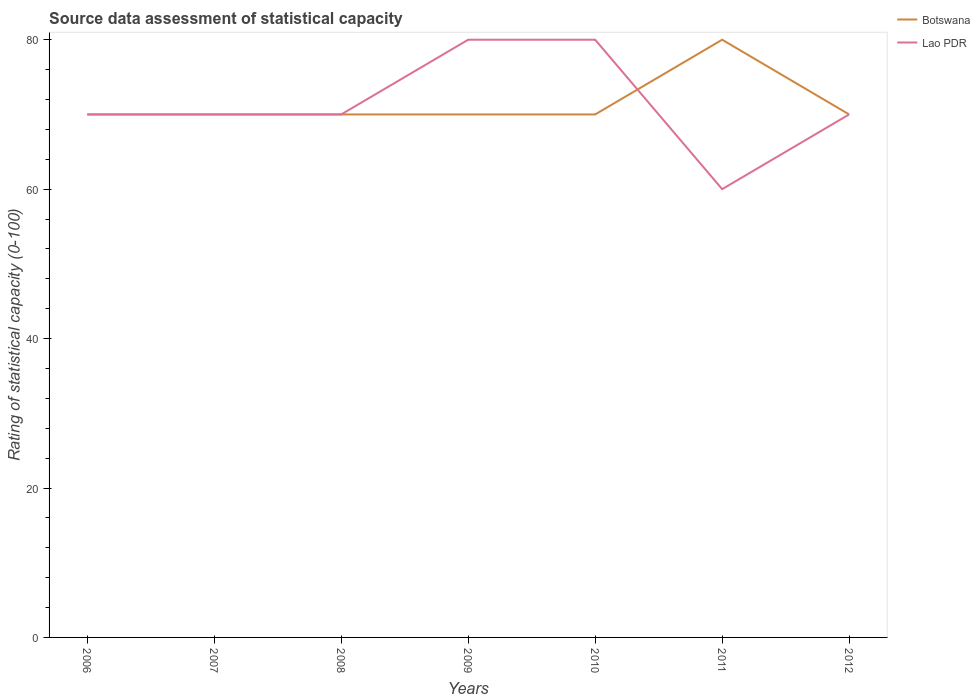Is the number of lines equal to the number of legend labels?
Your answer should be very brief. Yes. Across all years, what is the maximum rating of statistical capacity in Lao PDR?
Provide a succinct answer. 60. What is the total rating of statistical capacity in Botswana in the graph?
Make the answer very short. -10. What is the difference between the highest and the second highest rating of statistical capacity in Botswana?
Make the answer very short. 10. How many lines are there?
Your answer should be compact. 2. How many years are there in the graph?
Your answer should be compact. 7. Are the values on the major ticks of Y-axis written in scientific E-notation?
Your answer should be compact. No. Does the graph contain grids?
Offer a very short reply. No. Where does the legend appear in the graph?
Provide a succinct answer. Top right. What is the title of the graph?
Offer a very short reply. Source data assessment of statistical capacity. What is the label or title of the X-axis?
Your answer should be compact. Years. What is the label or title of the Y-axis?
Your answer should be very brief. Rating of statistical capacity (0-100). What is the Rating of statistical capacity (0-100) in Botswana in 2007?
Your answer should be compact. 70. What is the Rating of statistical capacity (0-100) in Lao PDR in 2007?
Give a very brief answer. 70. What is the Rating of statistical capacity (0-100) in Botswana in 2008?
Offer a very short reply. 70. What is the Rating of statistical capacity (0-100) of Lao PDR in 2008?
Offer a terse response. 70. What is the Rating of statistical capacity (0-100) of Lao PDR in 2010?
Offer a very short reply. 80. What is the Rating of statistical capacity (0-100) in Botswana in 2011?
Your answer should be very brief. 80. What is the Rating of statistical capacity (0-100) of Lao PDR in 2011?
Your answer should be very brief. 60. Across all years, what is the maximum Rating of statistical capacity (0-100) of Botswana?
Provide a short and direct response. 80. Across all years, what is the maximum Rating of statistical capacity (0-100) of Lao PDR?
Your response must be concise. 80. Across all years, what is the minimum Rating of statistical capacity (0-100) in Lao PDR?
Offer a very short reply. 60. What is the total Rating of statistical capacity (0-100) of Botswana in the graph?
Your answer should be compact. 500. What is the difference between the Rating of statistical capacity (0-100) in Botswana in 2006 and that in 2007?
Your answer should be very brief. 0. What is the difference between the Rating of statistical capacity (0-100) of Lao PDR in 2006 and that in 2007?
Provide a short and direct response. 0. What is the difference between the Rating of statistical capacity (0-100) of Botswana in 2006 and that in 2009?
Offer a very short reply. 0. What is the difference between the Rating of statistical capacity (0-100) of Botswana in 2006 and that in 2010?
Keep it short and to the point. 0. What is the difference between the Rating of statistical capacity (0-100) of Botswana in 2006 and that in 2011?
Give a very brief answer. -10. What is the difference between the Rating of statistical capacity (0-100) of Lao PDR in 2006 and that in 2011?
Provide a succinct answer. 10. What is the difference between the Rating of statistical capacity (0-100) of Botswana in 2007 and that in 2009?
Keep it short and to the point. 0. What is the difference between the Rating of statistical capacity (0-100) in Lao PDR in 2007 and that in 2009?
Give a very brief answer. -10. What is the difference between the Rating of statistical capacity (0-100) in Lao PDR in 2007 and that in 2010?
Provide a short and direct response. -10. What is the difference between the Rating of statistical capacity (0-100) of Botswana in 2007 and that in 2011?
Give a very brief answer. -10. What is the difference between the Rating of statistical capacity (0-100) in Lao PDR in 2007 and that in 2011?
Offer a terse response. 10. What is the difference between the Rating of statistical capacity (0-100) of Botswana in 2007 and that in 2012?
Make the answer very short. 0. What is the difference between the Rating of statistical capacity (0-100) of Botswana in 2008 and that in 2009?
Your response must be concise. 0. What is the difference between the Rating of statistical capacity (0-100) of Lao PDR in 2008 and that in 2010?
Your answer should be compact. -10. What is the difference between the Rating of statistical capacity (0-100) in Lao PDR in 2008 and that in 2011?
Make the answer very short. 10. What is the difference between the Rating of statistical capacity (0-100) in Botswana in 2008 and that in 2012?
Offer a terse response. 0. What is the difference between the Rating of statistical capacity (0-100) in Lao PDR in 2008 and that in 2012?
Offer a terse response. 0. What is the difference between the Rating of statistical capacity (0-100) in Botswana in 2009 and that in 2010?
Your response must be concise. 0. What is the difference between the Rating of statistical capacity (0-100) of Botswana in 2009 and that in 2012?
Your response must be concise. 0. What is the difference between the Rating of statistical capacity (0-100) in Lao PDR in 2010 and that in 2012?
Offer a very short reply. 10. What is the difference between the Rating of statistical capacity (0-100) of Botswana in 2006 and the Rating of statistical capacity (0-100) of Lao PDR in 2007?
Make the answer very short. 0. What is the difference between the Rating of statistical capacity (0-100) in Botswana in 2006 and the Rating of statistical capacity (0-100) in Lao PDR in 2008?
Ensure brevity in your answer.  0. What is the difference between the Rating of statistical capacity (0-100) in Botswana in 2007 and the Rating of statistical capacity (0-100) in Lao PDR in 2009?
Your response must be concise. -10. What is the difference between the Rating of statistical capacity (0-100) in Botswana in 2007 and the Rating of statistical capacity (0-100) in Lao PDR in 2010?
Your answer should be very brief. -10. What is the difference between the Rating of statistical capacity (0-100) of Botswana in 2008 and the Rating of statistical capacity (0-100) of Lao PDR in 2012?
Make the answer very short. 0. What is the difference between the Rating of statistical capacity (0-100) in Botswana in 2010 and the Rating of statistical capacity (0-100) in Lao PDR in 2011?
Your answer should be compact. 10. What is the difference between the Rating of statistical capacity (0-100) in Botswana in 2011 and the Rating of statistical capacity (0-100) in Lao PDR in 2012?
Your response must be concise. 10. What is the average Rating of statistical capacity (0-100) of Botswana per year?
Give a very brief answer. 71.43. What is the average Rating of statistical capacity (0-100) of Lao PDR per year?
Keep it short and to the point. 71.43. In the year 2007, what is the difference between the Rating of statistical capacity (0-100) of Botswana and Rating of statistical capacity (0-100) of Lao PDR?
Give a very brief answer. 0. In the year 2008, what is the difference between the Rating of statistical capacity (0-100) of Botswana and Rating of statistical capacity (0-100) of Lao PDR?
Offer a terse response. 0. In the year 2009, what is the difference between the Rating of statistical capacity (0-100) of Botswana and Rating of statistical capacity (0-100) of Lao PDR?
Your answer should be compact. -10. In the year 2010, what is the difference between the Rating of statistical capacity (0-100) in Botswana and Rating of statistical capacity (0-100) in Lao PDR?
Provide a short and direct response. -10. What is the ratio of the Rating of statistical capacity (0-100) in Lao PDR in 2006 to that in 2008?
Your response must be concise. 1. What is the ratio of the Rating of statistical capacity (0-100) of Botswana in 2006 to that in 2009?
Offer a terse response. 1. What is the ratio of the Rating of statistical capacity (0-100) of Lao PDR in 2006 to that in 2010?
Offer a terse response. 0.88. What is the ratio of the Rating of statistical capacity (0-100) of Botswana in 2007 to that in 2008?
Give a very brief answer. 1. What is the ratio of the Rating of statistical capacity (0-100) in Botswana in 2007 to that in 2010?
Your response must be concise. 1. What is the ratio of the Rating of statistical capacity (0-100) in Botswana in 2008 to that in 2009?
Your response must be concise. 1. What is the ratio of the Rating of statistical capacity (0-100) in Botswana in 2008 to that in 2011?
Provide a short and direct response. 0.88. What is the ratio of the Rating of statistical capacity (0-100) of Lao PDR in 2008 to that in 2011?
Give a very brief answer. 1.17. What is the ratio of the Rating of statistical capacity (0-100) in Lao PDR in 2008 to that in 2012?
Offer a very short reply. 1. What is the ratio of the Rating of statistical capacity (0-100) of Botswana in 2009 to that in 2011?
Your response must be concise. 0.88. What is the ratio of the Rating of statistical capacity (0-100) in Lao PDR in 2009 to that in 2012?
Offer a very short reply. 1.14. What is the ratio of the Rating of statistical capacity (0-100) of Botswana in 2010 to that in 2012?
Make the answer very short. 1. What is the ratio of the Rating of statistical capacity (0-100) of Lao PDR in 2010 to that in 2012?
Ensure brevity in your answer.  1.14. What is the difference between the highest and the lowest Rating of statistical capacity (0-100) in Lao PDR?
Your answer should be compact. 20. 